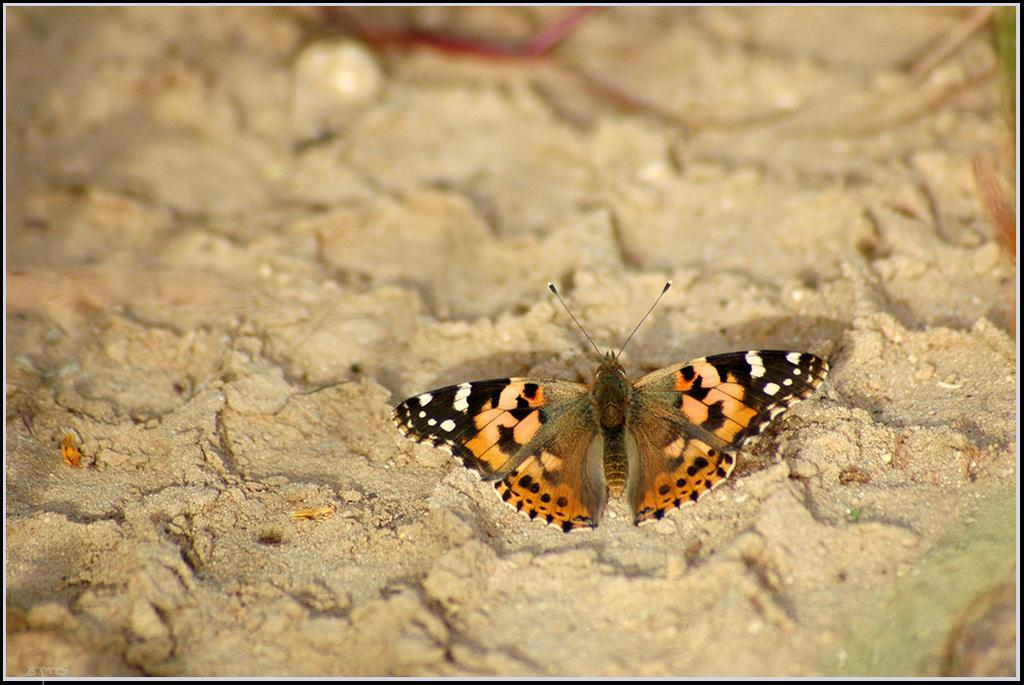What is the main subject of the image? There is a butterfly in the image. Where is the butterfly located? The butterfly is on the sand. Can you describe the top part of the image? The top part of the image is blurred. What type of root can be seen growing near the butterfly in the image? There is no root visible in the image; the butterfly is on the sand. What kind of business is being conducted in the image? There is no business activity depicted in the image; it features a butterfly on the sand. 